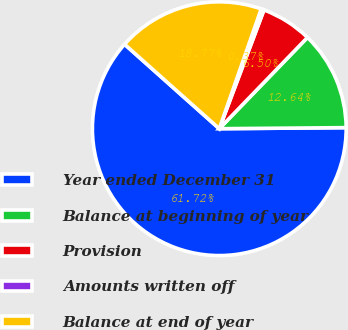Convert chart to OTSL. <chart><loc_0><loc_0><loc_500><loc_500><pie_chart><fcel>Year ended December 31<fcel>Balance at beginning of year<fcel>Provision<fcel>Amounts written off<fcel>Balance at end of year<nl><fcel>61.72%<fcel>12.64%<fcel>6.5%<fcel>0.37%<fcel>18.77%<nl></chart> 